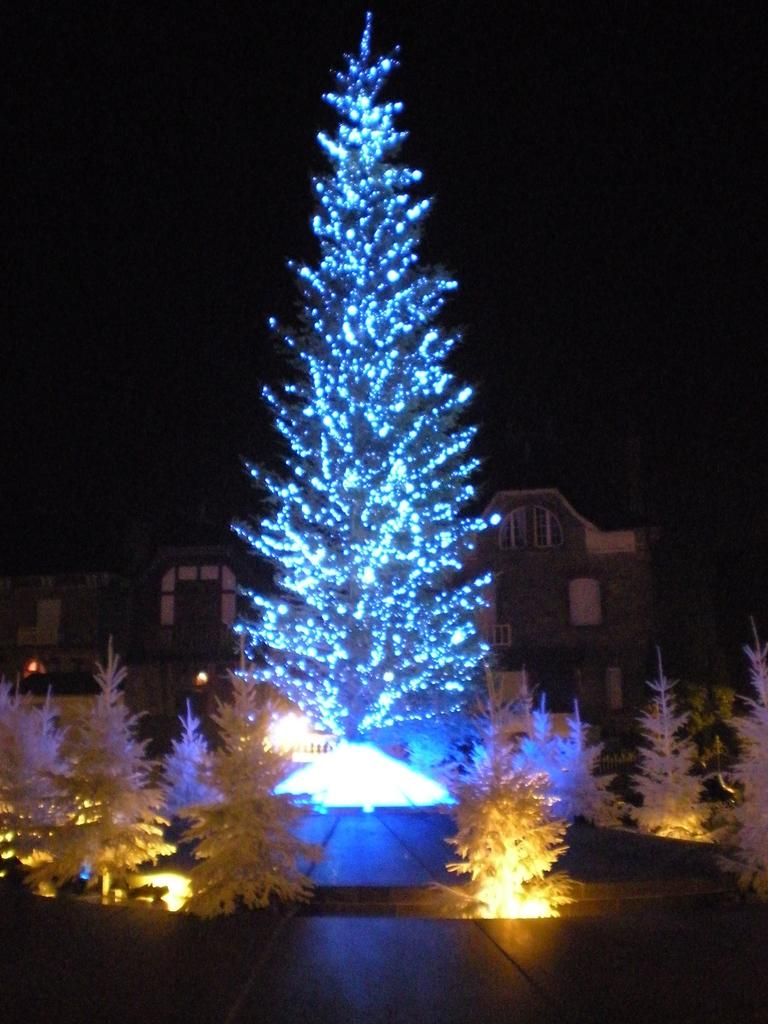What is the main subject in the center of the image? There are decorative plants in the center of the image. What can be seen in the background of the image? There are houses in the background of the image. How many sheep are visible in the image? There are no sheep present in the image. What type of boats can be seen in the image? There are no boats present in the image. 